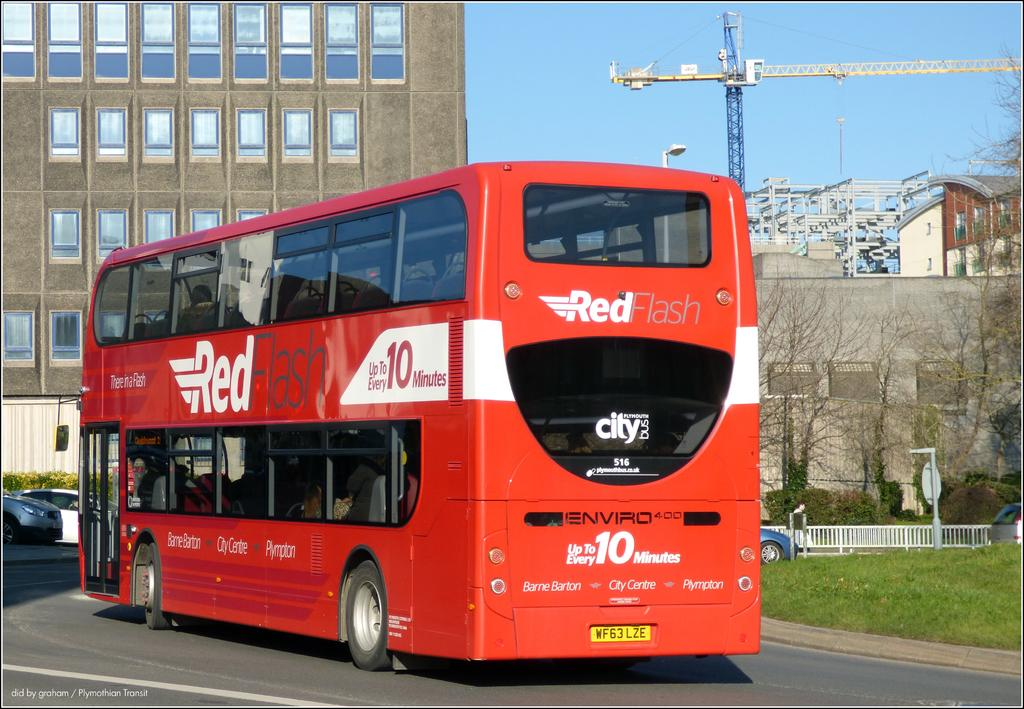<image>
Give a short and clear explanation of the subsequent image. Red Flash 516 is the name and number shown on the front of this public bus. 